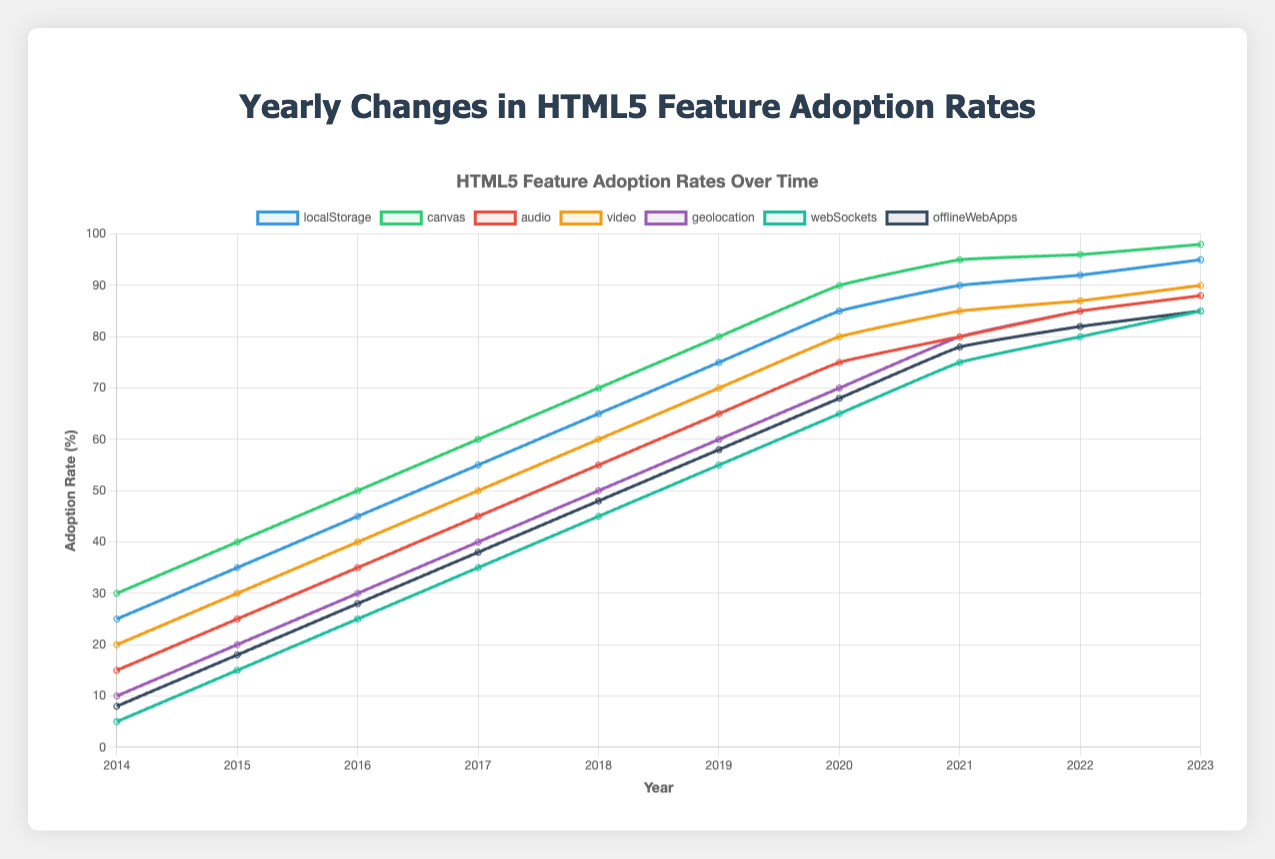What is the adoption rate of Canvas in 2020? Look for the value corresponding to Canvas in the year 2020 on the chart.
Answer: 90 Which HTML5 feature had the highest adoption rate in 2023 and what was the rate? Identify the highest line or point in 2023 and check which feature it corresponds to, and note the value.
Answer: Canvas, 98 Compare the adoption rates of Audio and Video in 2015. Which one was higher and by how much? Find the values for Audio and Video in 2015. Subtract the lower value from the higher value to find the difference.
Answer: Video, by 5% How much did the adoption rate of Geolocation increase from 2014 to 2023? Find the values for Geolocation in 2014 and 2023 and subtract the 2014 value from the 2023 value.
Answer: 78 What was the average adoption rate of Offline Web Apps between 2016 and 2020 inclusive? Add the yearly adoption rates of Offline Web Apps from 2016 to 2020 and divide by the number of years (5).
Answer: 50.8 Which year had the steepest increase in adoption rate for WebSockets? Compare the differences in adoption rates for WebSockets year over year and identify the year with the largest difference.
Answer: 2015 In which year did Local Storage surpass a 50% adoption rate? Look for the year when the Local Storage adoption rate exceeded 50%.
Answer: 2017 Compare the adoption rates of Geolocation and Offline Web Apps in 2019. Which one was higher and by how much? Find the values for Geolocation and Offline Web Apps in 2019. Subtract the lower value from the higher value to find the difference.
Answer: Geolocation, by 2% What was the combined adoption rate for Local Storage and Canvas in 2018? Add the adoption rates of Local Storage and Canvas in 2018.
Answer: 135 Which feature had the least adoption rate in 2014 and what was the rate? Identify the feature with the lowest point or value in 2014.
Answer: WebSockets, 5 